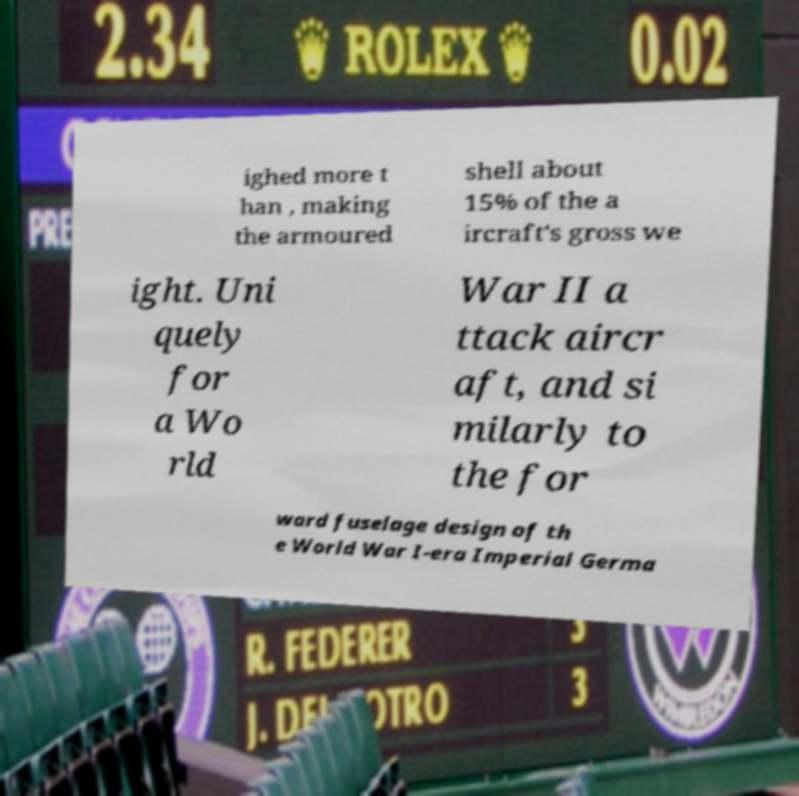For documentation purposes, I need the text within this image transcribed. Could you provide that? ighed more t han , making the armoured shell about 15% of the a ircraft's gross we ight. Uni quely for a Wo rld War II a ttack aircr aft, and si milarly to the for ward fuselage design of th e World War I-era Imperial Germa 